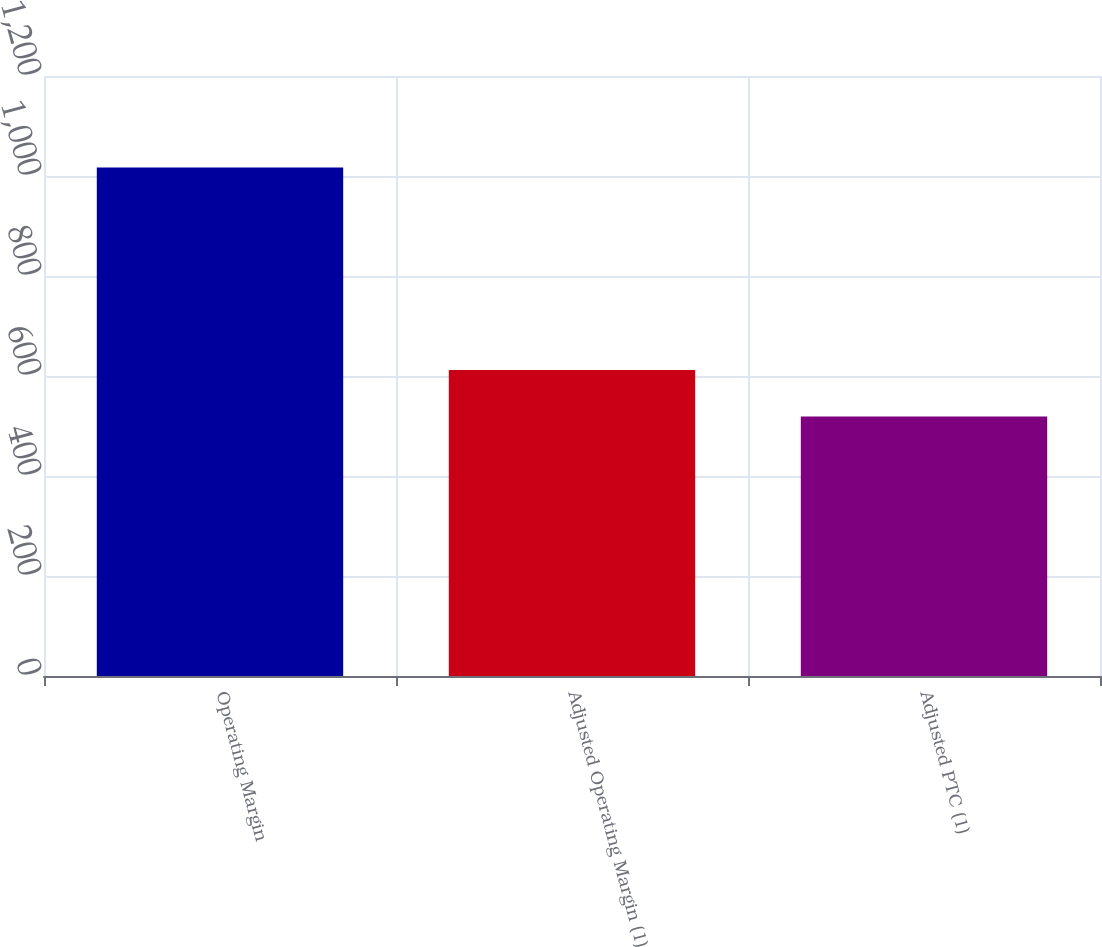Convert chart to OTSL. <chart><loc_0><loc_0><loc_500><loc_500><bar_chart><fcel>Operating Margin<fcel>Adjusted Operating Margin (1)<fcel>Adjusted PTC (1)<nl><fcel>1017<fcel>612<fcel>519<nl></chart> 